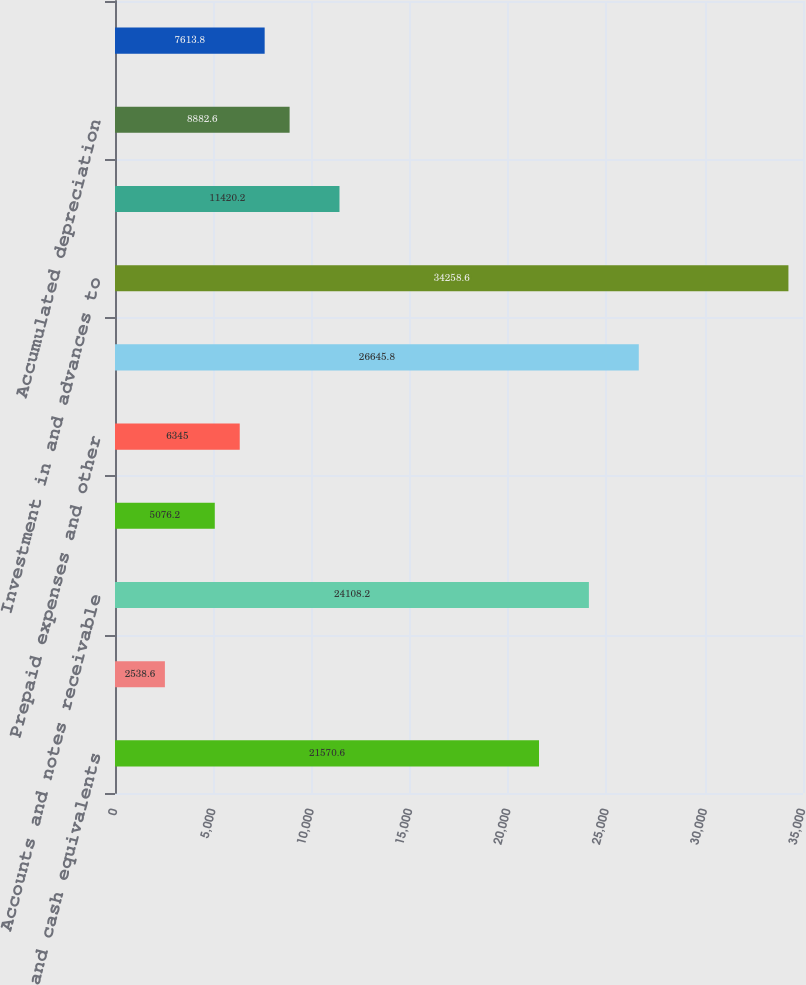<chart> <loc_0><loc_0><loc_500><loc_500><bar_chart><fcel>Cash and cash equivalents<fcel>Restricted cash<fcel>Accounts and notes receivable<fcel>Deferred income taxes<fcel>Prepaid expenses and other<fcel>Total current assets<fcel>Investment in and advances to<fcel>Cost<fcel>Accumulated depreciation<fcel>Office equipment net<nl><fcel>21570.6<fcel>2538.6<fcel>24108.2<fcel>5076.2<fcel>6345<fcel>26645.8<fcel>34258.6<fcel>11420.2<fcel>8882.6<fcel>7613.8<nl></chart> 